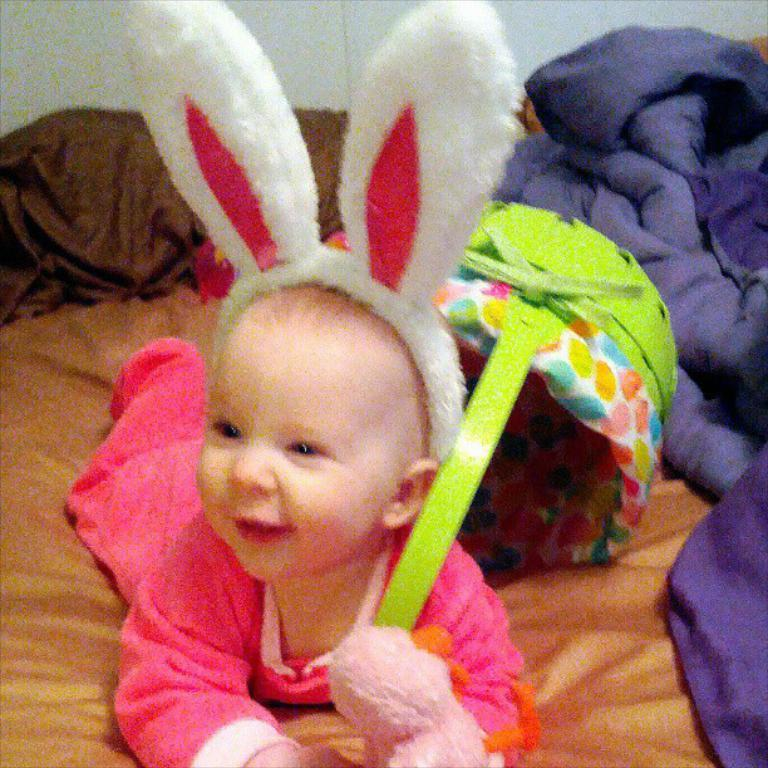What is the main subject of the picture? The main subject of the picture is a baby. Where is the baby located in the image? The baby is laying on a bed. What can be seen beside the baby on the bed? There is a bed sheet beside the baby. What color is the object behind the baby? There is a green color object behind the baby. What type of card can be seen in the baby's hand in the image? There is no card present in the baby's hand in the image. What time of day is it in the image, considering the lighting and shadows? The provided facts do not give enough information to determine the time of day in the image. 